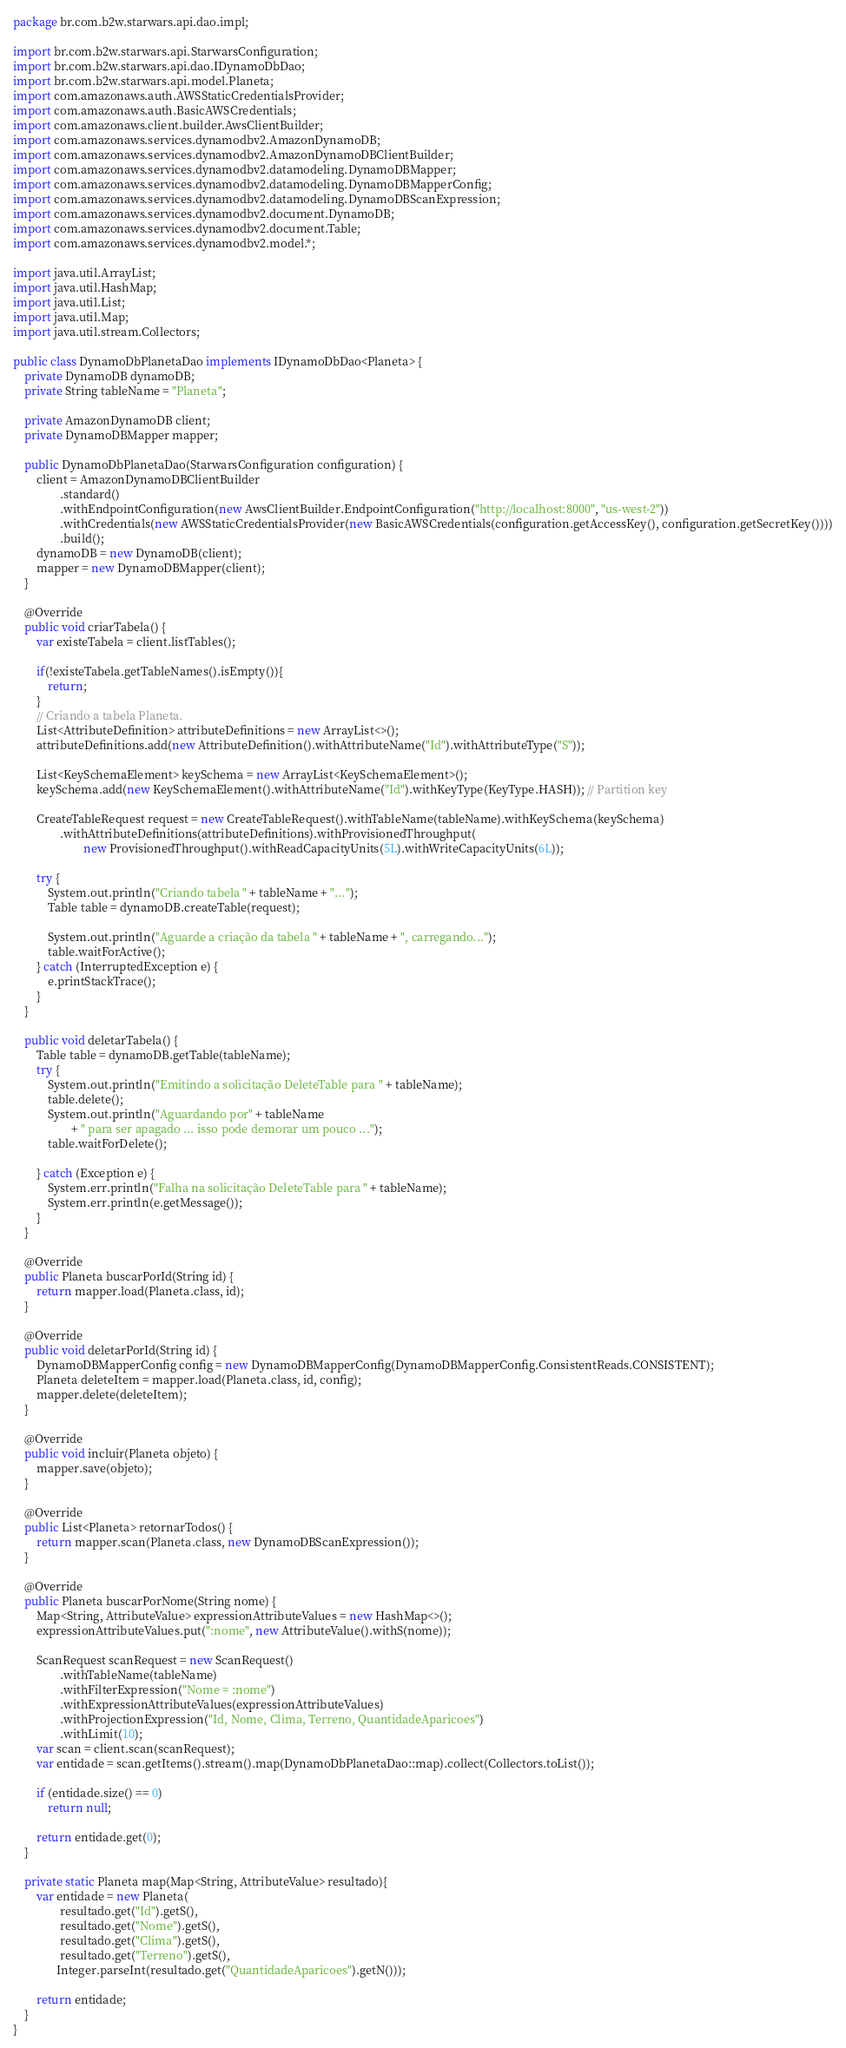<code> <loc_0><loc_0><loc_500><loc_500><_Java_>package br.com.b2w.starwars.api.dao.impl;

import br.com.b2w.starwars.api.StarwarsConfiguration;
import br.com.b2w.starwars.api.dao.IDynamoDbDao;
import br.com.b2w.starwars.api.model.Planeta;
import com.amazonaws.auth.AWSStaticCredentialsProvider;
import com.amazonaws.auth.BasicAWSCredentials;
import com.amazonaws.client.builder.AwsClientBuilder;
import com.amazonaws.services.dynamodbv2.AmazonDynamoDB;
import com.amazonaws.services.dynamodbv2.AmazonDynamoDBClientBuilder;
import com.amazonaws.services.dynamodbv2.datamodeling.DynamoDBMapper;
import com.amazonaws.services.dynamodbv2.datamodeling.DynamoDBMapperConfig;
import com.amazonaws.services.dynamodbv2.datamodeling.DynamoDBScanExpression;
import com.amazonaws.services.dynamodbv2.document.DynamoDB;
import com.amazonaws.services.dynamodbv2.document.Table;
import com.amazonaws.services.dynamodbv2.model.*;

import java.util.ArrayList;
import java.util.HashMap;
import java.util.List;
import java.util.Map;
import java.util.stream.Collectors;

public class DynamoDbPlanetaDao implements IDynamoDbDao<Planeta> {
    private DynamoDB dynamoDB;
    private String tableName = "Planeta";

    private AmazonDynamoDB client;
    private DynamoDBMapper mapper;

    public DynamoDbPlanetaDao(StarwarsConfiguration configuration) {
        client = AmazonDynamoDBClientBuilder
                .standard()
                .withEndpointConfiguration(new AwsClientBuilder.EndpointConfiguration("http://localhost:8000", "us-west-2"))
                .withCredentials(new AWSStaticCredentialsProvider(new BasicAWSCredentials(configuration.getAccessKey(), configuration.getSecretKey())))
                .build();
        dynamoDB = new DynamoDB(client);
        mapper = new DynamoDBMapper(client);
    }

    @Override
    public void criarTabela() {
        var existeTabela = client.listTables();

        if(!existeTabela.getTableNames().isEmpty()){
            return;
        }
        // Criando a tabela Planeta.
        List<AttributeDefinition> attributeDefinitions = new ArrayList<>();
        attributeDefinitions.add(new AttributeDefinition().withAttributeName("Id").withAttributeType("S"));

        List<KeySchemaElement> keySchema = new ArrayList<KeySchemaElement>();
        keySchema.add(new KeySchemaElement().withAttributeName("Id").withKeyType(KeyType.HASH)); // Partition key

        CreateTableRequest request = new CreateTableRequest().withTableName(tableName).withKeySchema(keySchema)
                .withAttributeDefinitions(attributeDefinitions).withProvisionedThroughput(
                        new ProvisionedThroughput().withReadCapacityUnits(5L).withWriteCapacityUnits(6L));

        try {
            System.out.println("Criando tabela " + tableName + "...");
            Table table = dynamoDB.createTable(request);

            System.out.println("Aguarde a criação da tabela " + tableName + ", carregando...");
            table.waitForActive();
        } catch (InterruptedException e) {
            e.printStackTrace();
        }
    }

    public void deletarTabela() {
        Table table = dynamoDB.getTable(tableName);
        try {
            System.out.println("Emitindo a solicitação DeleteTable para " + tableName);
            table.delete();
            System.out.println("Aguardando por" + tableName
                    + " para ser apagado ... isso pode demorar um pouco ...");
            table.waitForDelete();

        } catch (Exception e) {
            System.err.println("Falha na solicitação DeleteTable para " + tableName);
            System.err.println(e.getMessage());
        }
    }

    @Override
    public Planeta buscarPorId(String id) {
        return mapper.load(Planeta.class, id);
    }

    @Override
    public void deletarPorId(String id) {
        DynamoDBMapperConfig config = new DynamoDBMapperConfig(DynamoDBMapperConfig.ConsistentReads.CONSISTENT);
        Planeta deleteItem = mapper.load(Planeta.class, id, config);
        mapper.delete(deleteItem);
    }

    @Override
    public void incluir(Planeta objeto) {
        mapper.save(objeto);
    }

    @Override
    public List<Planeta> retornarTodos() {
        return mapper.scan(Planeta.class, new DynamoDBScanExpression());
    }

    @Override
    public Planeta buscarPorNome(String nome) {
        Map<String, AttributeValue> expressionAttributeValues = new HashMap<>();
        expressionAttributeValues.put(":nome", new AttributeValue().withS(nome));

        ScanRequest scanRequest = new ScanRequest()
                .withTableName(tableName)
                .withFilterExpression("Nome = :nome")
                .withExpressionAttributeValues(expressionAttributeValues)
                .withProjectionExpression("Id, Nome, Clima, Terreno, QuantidadeAparicoes")
                .withLimit(10);
        var scan = client.scan(scanRequest);
        var entidade = scan.getItems().stream().map(DynamoDbPlanetaDao::map).collect(Collectors.toList());

        if (entidade.size() == 0)
            return null;

        return entidade.get(0);
    }

    private static Planeta map(Map<String, AttributeValue> resultado){
        var entidade = new Planeta(
                resultado.get("Id").getS(),
                resultado.get("Nome").getS(),
                resultado.get("Clima").getS(),
                resultado.get("Terreno").getS(),
               Integer.parseInt(resultado.get("QuantidadeAparicoes").getN()));

        return entidade;
    }
}
</code> 